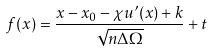<formula> <loc_0><loc_0><loc_500><loc_500>f ( x ) = \frac { x - x _ { 0 } - \chi u ^ { \prime } ( x ) + k } { \sqrt { n \Delta \Omega } } + t</formula> 